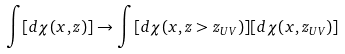Convert formula to latex. <formula><loc_0><loc_0><loc_500><loc_500>\int [ d \chi ( x , z ) ] \to \int [ d \chi ( x , z > z _ { U V } ) ] [ d \chi ( x , z _ { U V } ) ]</formula> 